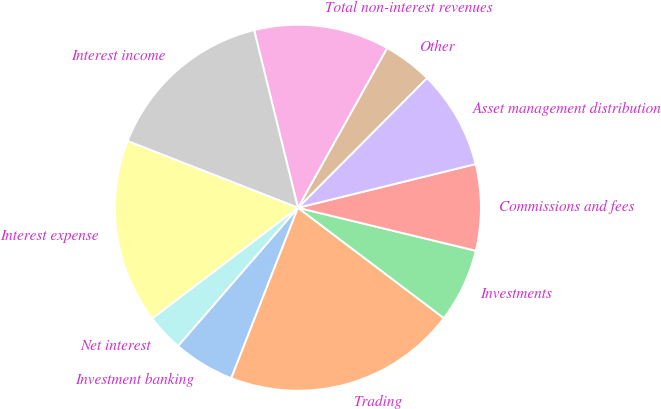Convert chart. <chart><loc_0><loc_0><loc_500><loc_500><pie_chart><fcel>Investment banking<fcel>Trading<fcel>Investments<fcel>Commissions and fees<fcel>Asset management distribution<fcel>Other<fcel>Total non-interest revenues<fcel>Interest income<fcel>Interest expense<fcel>Net interest<nl><fcel>5.44%<fcel>20.63%<fcel>6.53%<fcel>7.61%<fcel>8.7%<fcel>4.36%<fcel>11.95%<fcel>15.21%<fcel>16.29%<fcel>3.27%<nl></chart> 